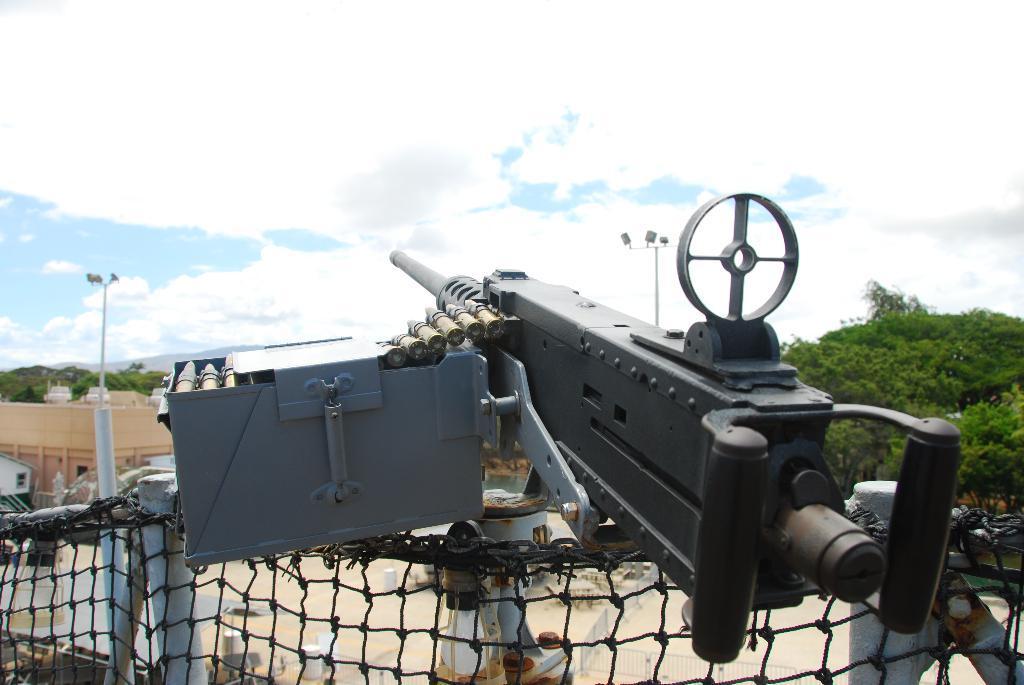In one or two sentences, can you explain what this image depicts? We can see gun with box and bullets on net and we can see rods. In the background we can see pole, building, trees and sky with clouds. 